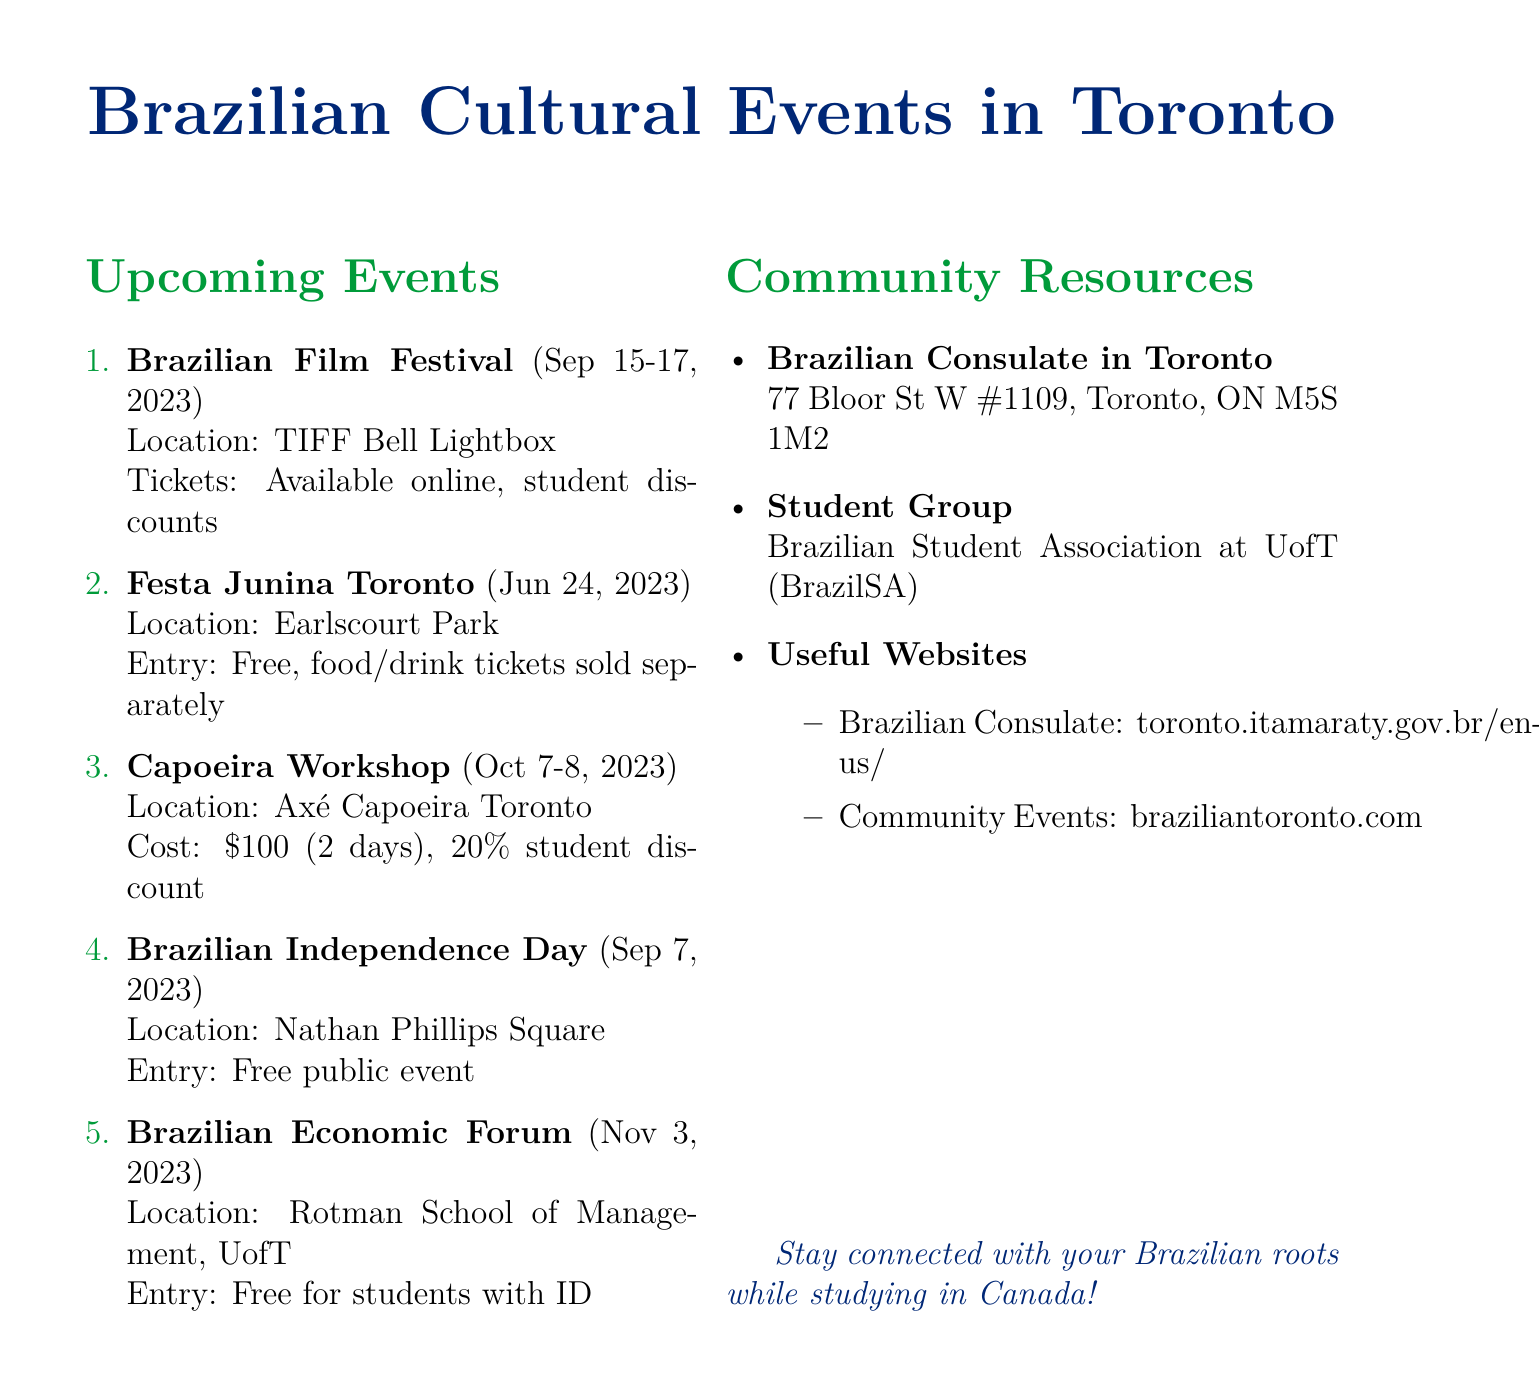What are the dates of the Brazilian Film Festival? The document provides the specific dates for the Brazilian Film Festival as September 15-17, 2023.
Answer: September 15-17, 2023 Where is the Capoeira Workshop being held? The location of the Capoeira Workshop is specified in the document as Axé Capoeira Toronto.
Answer: Axé Capoeira Toronto What is the cost of the Capoeira Workshop for one day? The document mentions the cost for attending one day of the Capoeira Workshop is $60.
Answer: $60 How is participation in the Brazilian Independence Day Celebration? The document states that the Brazilian Independence Day Celebration is a free event open to the public.
Answer: Free event What is the relevance of the Brazilian Economic Forum? The document indicates that it is highly relevant to studies in economics and provides networking opportunities.
Answer: Relevant to studies in economics What type of event is Festa Junina Toronto? The document describes Festa Junina Toronto as a traditional Brazilian winter harvest festival.
Answer: Traditional Brazilian winter harvest festival When is the next upcoming cultural event listed in the document? The document lists the upcoming events in chronological order, making it clear that the next event is the Capoeira Workshop, which is on October 7-8, 2023.
Answer: October 7-8, 2023 What organization is mentioned for Brazilian students at the University of Toronto? The document mentions the Brazilian Student Association at the University of Toronto (BrazilSA) as the student group relevant to Brazilians.
Answer: Brazilian Student Association at University of Toronto (BrazilSA) 